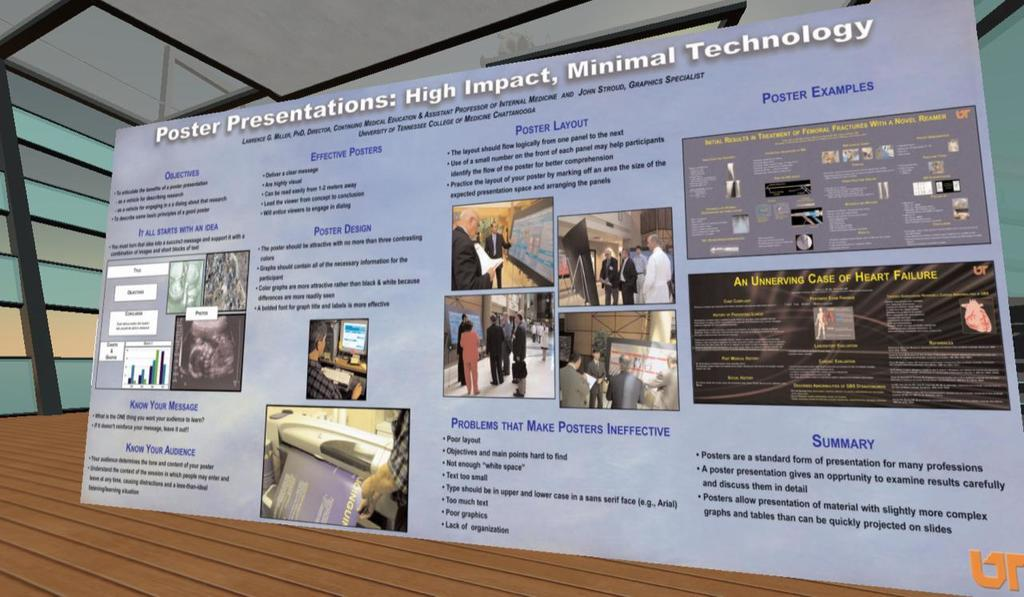Provide a one-sentence caption for the provided image. A poster supporting poster presentations lists the many benefits of that form of presentation. 